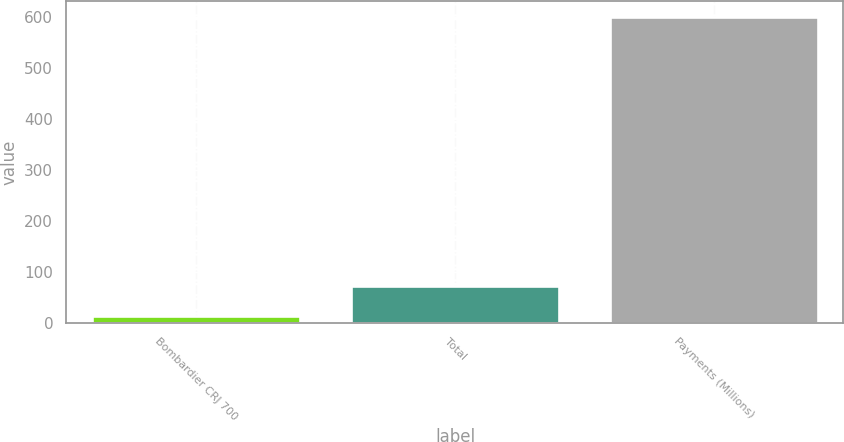Convert chart to OTSL. <chart><loc_0><loc_0><loc_500><loc_500><bar_chart><fcel>Bombardier CRJ 700<fcel>Total<fcel>Payments (Millions)<nl><fcel>14<fcel>72.7<fcel>601<nl></chart> 